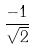<formula> <loc_0><loc_0><loc_500><loc_500>\frac { - 1 } { \sqrt { 2 } }</formula> 